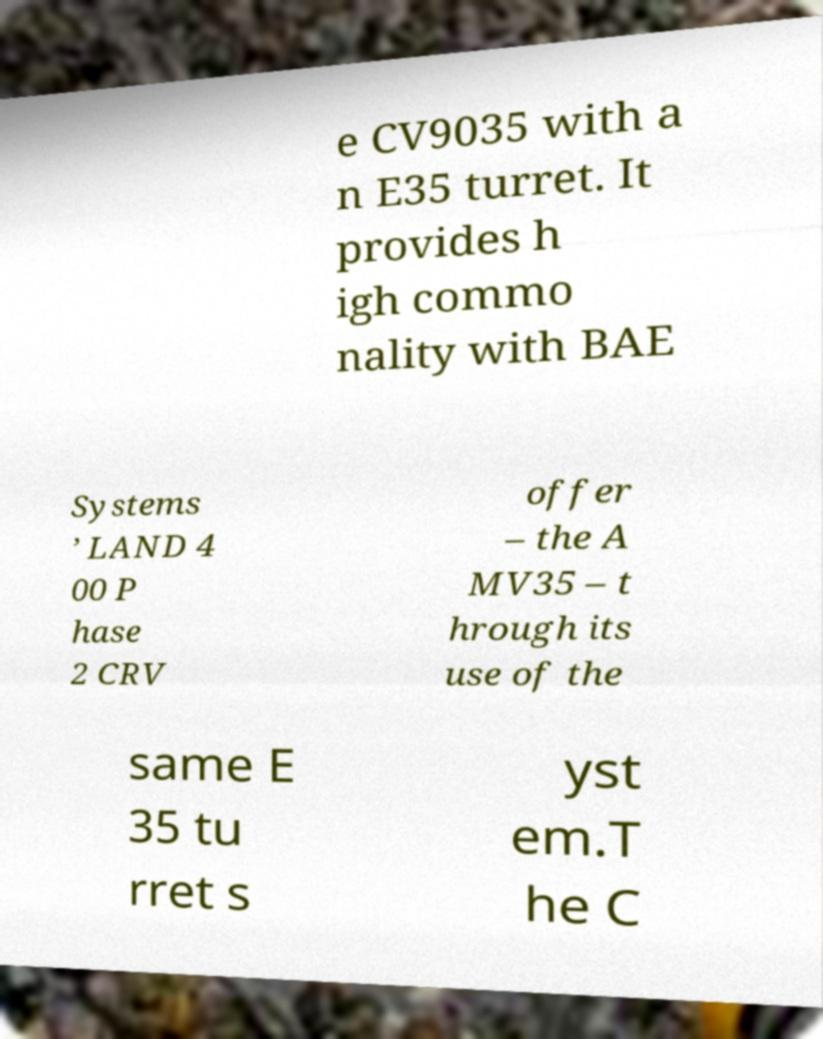For documentation purposes, I need the text within this image transcribed. Could you provide that? e CV9035 with a n E35 turret. It provides h igh commo nality with BAE Systems ’ LAND 4 00 P hase 2 CRV offer – the A MV35 – t hrough its use of the same E 35 tu rret s yst em.T he C 